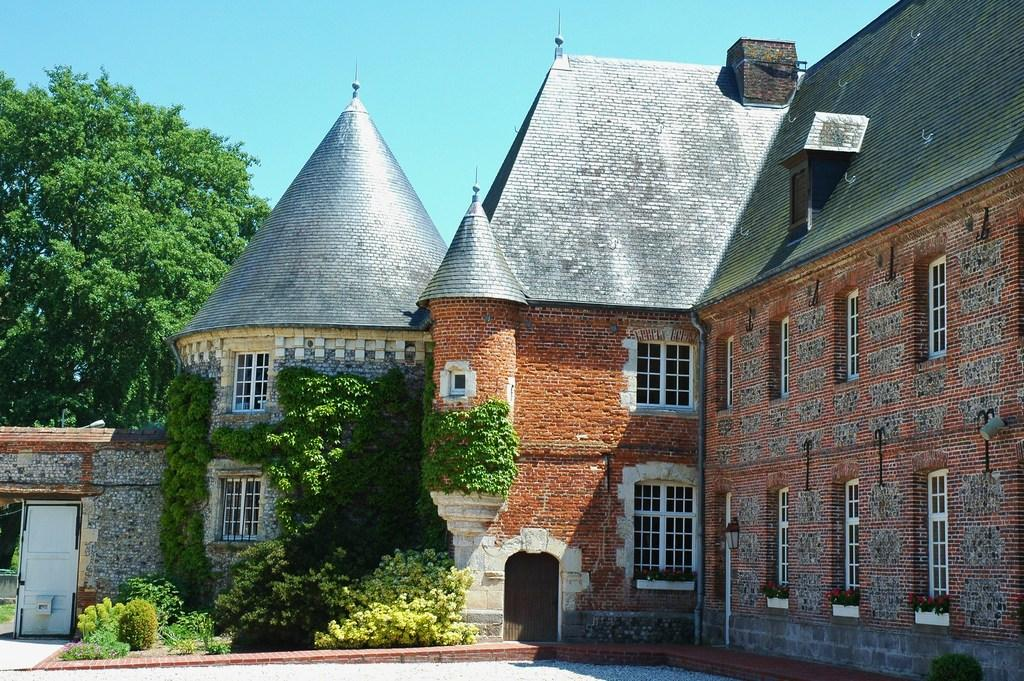What type of structure is visible in the image? There is a building in the image. What feature can be seen on the building? The building has windows. What type of vegetation is present on the left side of the image? There is grass, plants, and trees on the left side of the image. What part of the natural environment is visible in the image? The sky is visible in the image. Can you describe the unspecified object on the ground on the left side of the image? Unfortunately, the facts provided do not give enough information to describe the unspecified object on the ground. What advertisement can be seen on the building in the image? There is no advertisement visible on the building in the image. How long does it take for the minute hand to move around the clock in the image? There is no clock present in the image, so it is not possible to determine how long it takes for the minute hand to move around. 